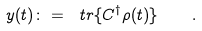<formula> <loc_0><loc_0><loc_500><loc_500>y ( t ) \colon = \ t r \{ C ^ { \dagger } \rho ( t ) \} \quad .</formula> 